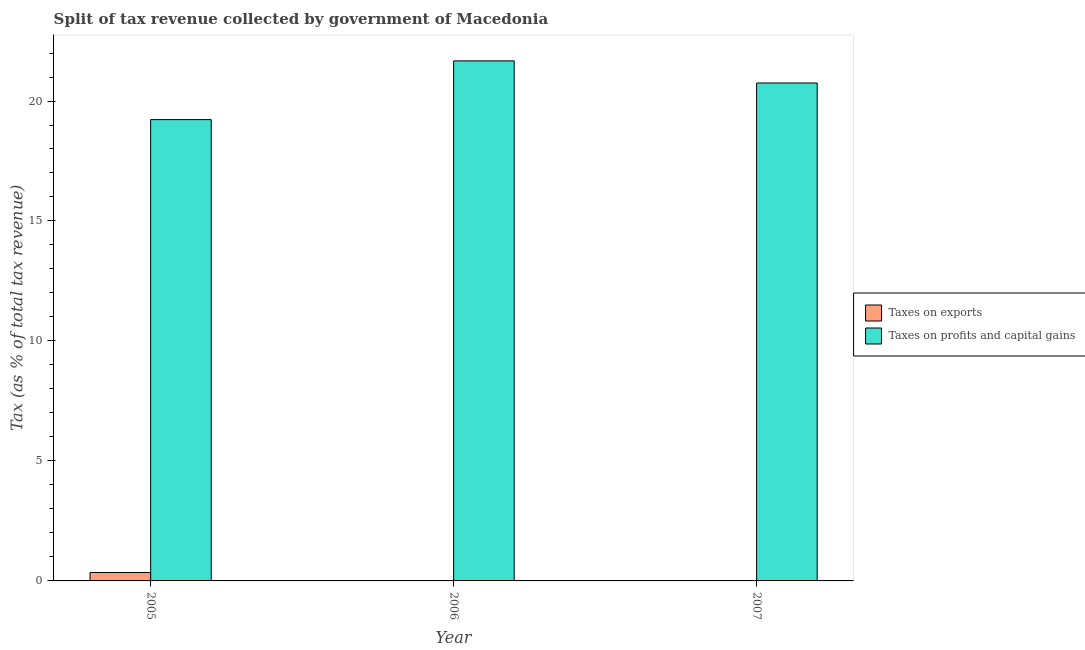How many different coloured bars are there?
Your answer should be very brief. 2. How many groups of bars are there?
Give a very brief answer. 3. Are the number of bars on each tick of the X-axis equal?
Provide a short and direct response. Yes. How many bars are there on the 1st tick from the left?
Give a very brief answer. 2. How many bars are there on the 3rd tick from the right?
Ensure brevity in your answer.  2. What is the percentage of revenue obtained from taxes on exports in 2005?
Provide a short and direct response. 0.35. Across all years, what is the maximum percentage of revenue obtained from taxes on exports?
Give a very brief answer. 0.35. Across all years, what is the minimum percentage of revenue obtained from taxes on exports?
Offer a terse response. 1.83851793347189e-5. What is the total percentage of revenue obtained from taxes on profits and capital gains in the graph?
Make the answer very short. 61.65. What is the difference between the percentage of revenue obtained from taxes on profits and capital gains in 2006 and that in 2007?
Make the answer very short. 0.92. What is the difference between the percentage of revenue obtained from taxes on exports in 2005 and the percentage of revenue obtained from taxes on profits and capital gains in 2007?
Offer a terse response. 0.35. What is the average percentage of revenue obtained from taxes on profits and capital gains per year?
Make the answer very short. 20.55. In the year 2005, what is the difference between the percentage of revenue obtained from taxes on exports and percentage of revenue obtained from taxes on profits and capital gains?
Provide a succinct answer. 0. What is the ratio of the percentage of revenue obtained from taxes on exports in 2006 to that in 2007?
Ensure brevity in your answer.  350.05. Is the percentage of revenue obtained from taxes on exports in 2005 less than that in 2007?
Give a very brief answer. No. Is the difference between the percentage of revenue obtained from taxes on profits and capital gains in 2006 and 2007 greater than the difference between the percentage of revenue obtained from taxes on exports in 2006 and 2007?
Offer a very short reply. No. What is the difference between the highest and the second highest percentage of revenue obtained from taxes on profits and capital gains?
Your response must be concise. 0.92. What is the difference between the highest and the lowest percentage of revenue obtained from taxes on exports?
Provide a succinct answer. 0.35. In how many years, is the percentage of revenue obtained from taxes on profits and capital gains greater than the average percentage of revenue obtained from taxes on profits and capital gains taken over all years?
Offer a terse response. 2. Is the sum of the percentage of revenue obtained from taxes on profits and capital gains in 2006 and 2007 greater than the maximum percentage of revenue obtained from taxes on exports across all years?
Keep it short and to the point. Yes. What does the 2nd bar from the left in 2007 represents?
Give a very brief answer. Taxes on profits and capital gains. What does the 2nd bar from the right in 2006 represents?
Ensure brevity in your answer.  Taxes on exports. Are all the bars in the graph horizontal?
Your answer should be very brief. No. How many years are there in the graph?
Your answer should be very brief. 3. Does the graph contain any zero values?
Provide a short and direct response. No. How many legend labels are there?
Give a very brief answer. 2. What is the title of the graph?
Offer a very short reply. Split of tax revenue collected by government of Macedonia. Does "Largest city" appear as one of the legend labels in the graph?
Ensure brevity in your answer.  No. What is the label or title of the Y-axis?
Provide a short and direct response. Tax (as % of total tax revenue). What is the Tax (as % of total tax revenue) in Taxes on exports in 2005?
Give a very brief answer. 0.35. What is the Tax (as % of total tax revenue) in Taxes on profits and capital gains in 2005?
Provide a short and direct response. 19.22. What is the Tax (as % of total tax revenue) of Taxes on exports in 2006?
Provide a succinct answer. 0.01. What is the Tax (as % of total tax revenue) of Taxes on profits and capital gains in 2006?
Ensure brevity in your answer.  21.67. What is the Tax (as % of total tax revenue) in Taxes on exports in 2007?
Keep it short and to the point. 1.83851793347189e-5. What is the Tax (as % of total tax revenue) of Taxes on profits and capital gains in 2007?
Provide a short and direct response. 20.75. Across all years, what is the maximum Tax (as % of total tax revenue) of Taxes on exports?
Provide a short and direct response. 0.35. Across all years, what is the maximum Tax (as % of total tax revenue) in Taxes on profits and capital gains?
Provide a succinct answer. 21.67. Across all years, what is the minimum Tax (as % of total tax revenue) of Taxes on exports?
Keep it short and to the point. 1.83851793347189e-5. Across all years, what is the minimum Tax (as % of total tax revenue) of Taxes on profits and capital gains?
Give a very brief answer. 19.22. What is the total Tax (as % of total tax revenue) of Taxes on exports in the graph?
Provide a succinct answer. 0.36. What is the total Tax (as % of total tax revenue) of Taxes on profits and capital gains in the graph?
Provide a short and direct response. 61.65. What is the difference between the Tax (as % of total tax revenue) of Taxes on exports in 2005 and that in 2006?
Ensure brevity in your answer.  0.34. What is the difference between the Tax (as % of total tax revenue) in Taxes on profits and capital gains in 2005 and that in 2006?
Make the answer very short. -2.45. What is the difference between the Tax (as % of total tax revenue) of Taxes on exports in 2005 and that in 2007?
Keep it short and to the point. 0.35. What is the difference between the Tax (as % of total tax revenue) of Taxes on profits and capital gains in 2005 and that in 2007?
Your answer should be compact. -1.53. What is the difference between the Tax (as % of total tax revenue) of Taxes on exports in 2006 and that in 2007?
Make the answer very short. 0.01. What is the difference between the Tax (as % of total tax revenue) in Taxes on profits and capital gains in 2006 and that in 2007?
Your answer should be very brief. 0.92. What is the difference between the Tax (as % of total tax revenue) in Taxes on exports in 2005 and the Tax (as % of total tax revenue) in Taxes on profits and capital gains in 2006?
Your answer should be very brief. -21.32. What is the difference between the Tax (as % of total tax revenue) of Taxes on exports in 2005 and the Tax (as % of total tax revenue) of Taxes on profits and capital gains in 2007?
Provide a succinct answer. -20.4. What is the difference between the Tax (as % of total tax revenue) of Taxes on exports in 2006 and the Tax (as % of total tax revenue) of Taxes on profits and capital gains in 2007?
Offer a very short reply. -20.74. What is the average Tax (as % of total tax revenue) in Taxes on exports per year?
Offer a terse response. 0.12. What is the average Tax (as % of total tax revenue) in Taxes on profits and capital gains per year?
Give a very brief answer. 20.55. In the year 2005, what is the difference between the Tax (as % of total tax revenue) in Taxes on exports and Tax (as % of total tax revenue) in Taxes on profits and capital gains?
Ensure brevity in your answer.  -18.87. In the year 2006, what is the difference between the Tax (as % of total tax revenue) in Taxes on exports and Tax (as % of total tax revenue) in Taxes on profits and capital gains?
Keep it short and to the point. -21.67. In the year 2007, what is the difference between the Tax (as % of total tax revenue) in Taxes on exports and Tax (as % of total tax revenue) in Taxes on profits and capital gains?
Your response must be concise. -20.75. What is the ratio of the Tax (as % of total tax revenue) of Taxes on exports in 2005 to that in 2006?
Your answer should be very brief. 54.45. What is the ratio of the Tax (as % of total tax revenue) of Taxes on profits and capital gains in 2005 to that in 2006?
Your answer should be compact. 0.89. What is the ratio of the Tax (as % of total tax revenue) of Taxes on exports in 2005 to that in 2007?
Provide a succinct answer. 1.91e+04. What is the ratio of the Tax (as % of total tax revenue) in Taxes on profits and capital gains in 2005 to that in 2007?
Offer a terse response. 0.93. What is the ratio of the Tax (as % of total tax revenue) in Taxes on exports in 2006 to that in 2007?
Your answer should be compact. 350.05. What is the ratio of the Tax (as % of total tax revenue) of Taxes on profits and capital gains in 2006 to that in 2007?
Provide a short and direct response. 1.04. What is the difference between the highest and the second highest Tax (as % of total tax revenue) of Taxes on exports?
Your answer should be compact. 0.34. What is the difference between the highest and the second highest Tax (as % of total tax revenue) of Taxes on profits and capital gains?
Your answer should be very brief. 0.92. What is the difference between the highest and the lowest Tax (as % of total tax revenue) in Taxes on exports?
Give a very brief answer. 0.35. What is the difference between the highest and the lowest Tax (as % of total tax revenue) in Taxes on profits and capital gains?
Provide a short and direct response. 2.45. 